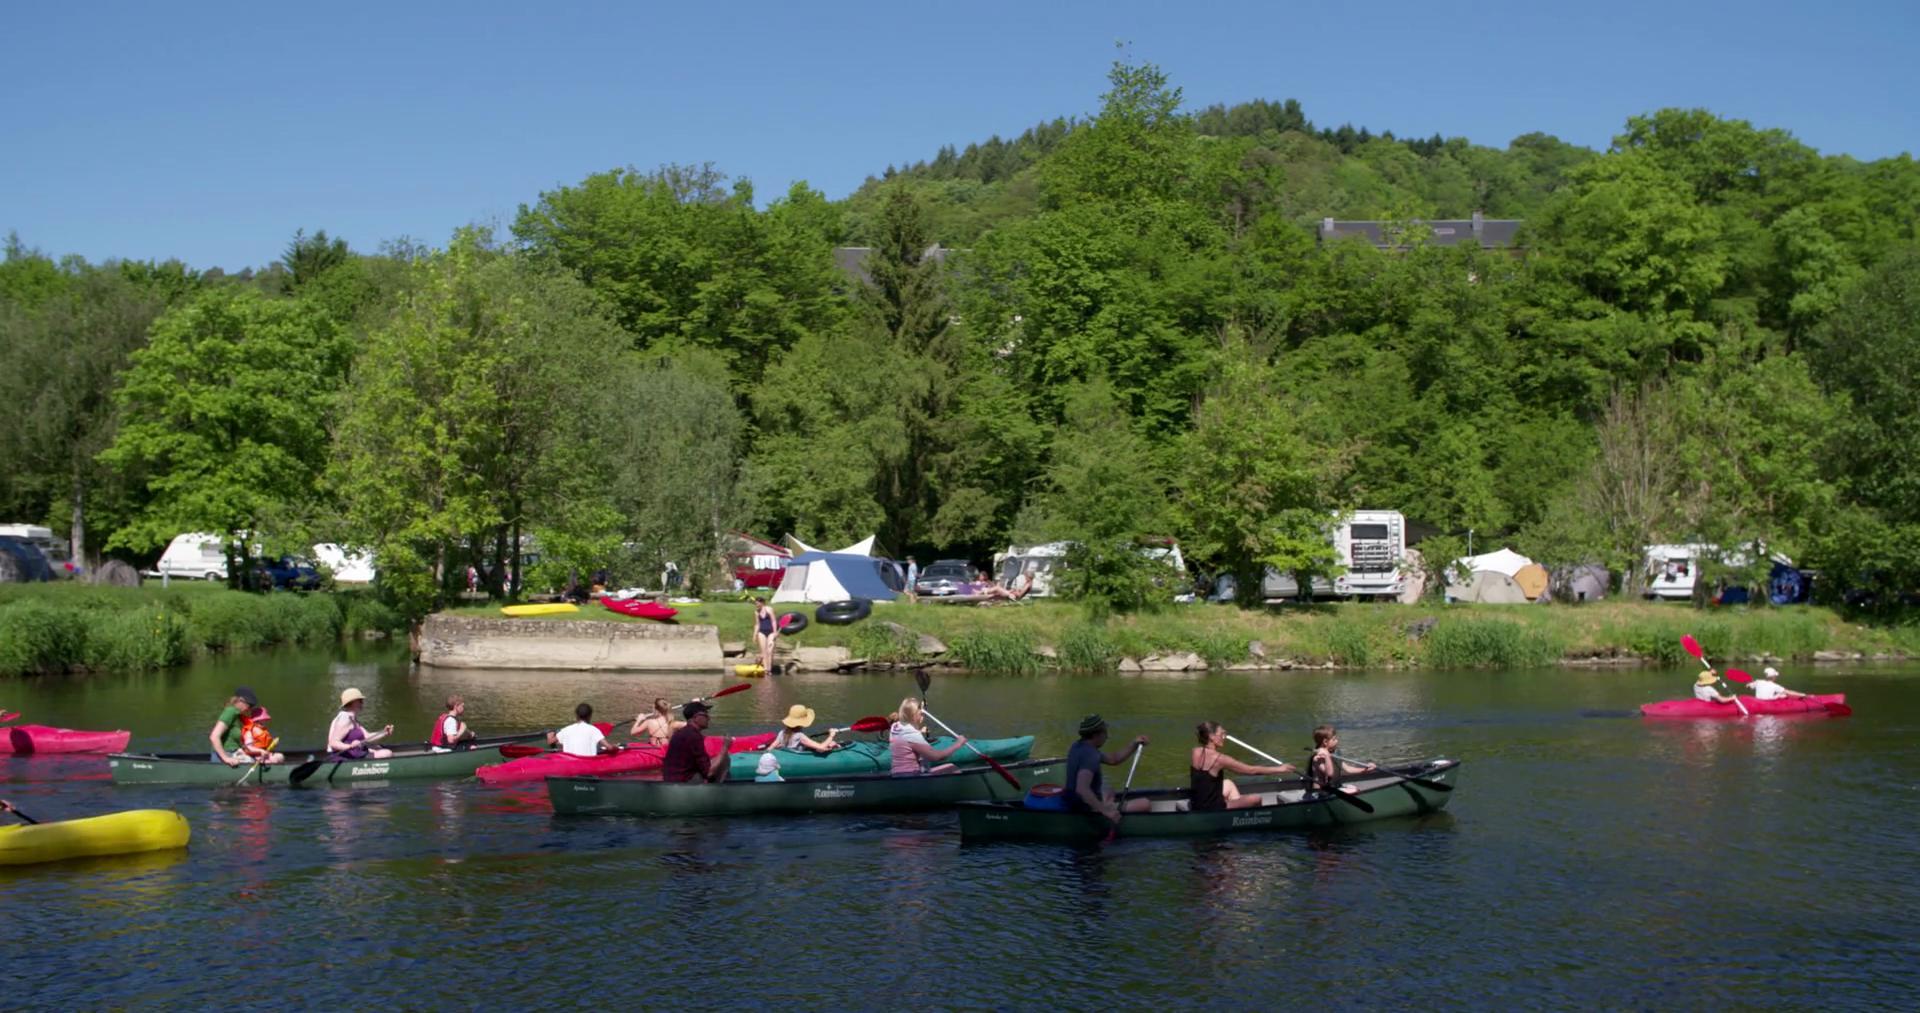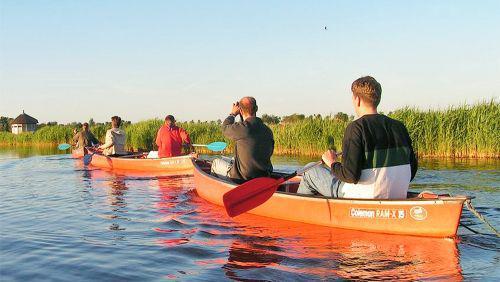The first image is the image on the left, the second image is the image on the right. Analyze the images presented: Is the assertion "There are exactly three canoes." valid? Answer yes or no. No. The first image is the image on the left, the second image is the image on the right. Examine the images to the left and right. Is the description "The right image contains exactly two side-by-side canoes which are on the water and angled forward." accurate? Answer yes or no. No. 